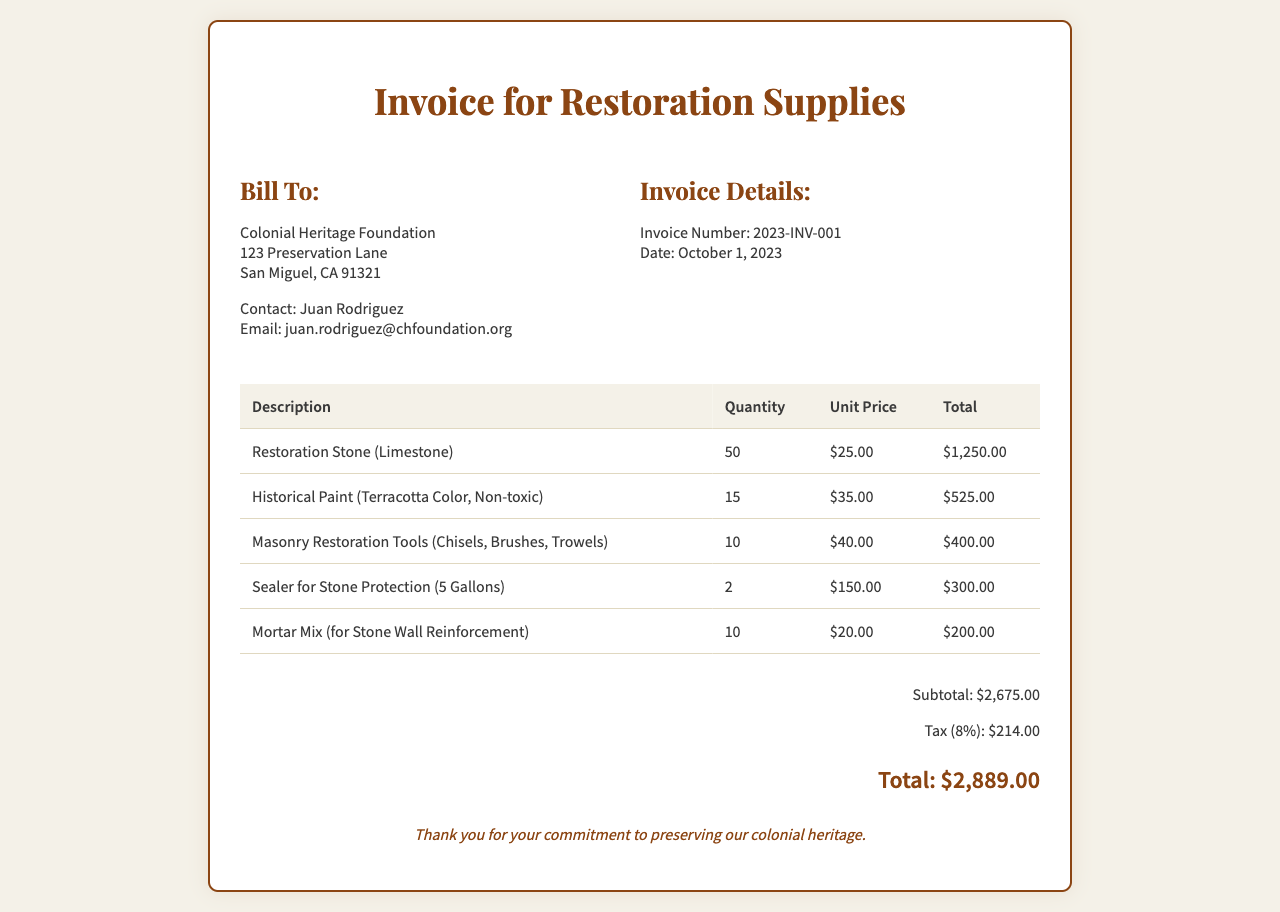What is the invoice number? The invoice number is provided in the invoice details section labeled as "Invoice Number."
Answer: 2023-INV-001 Who is the contact person for the Colonial Heritage Foundation? The contact person is listed under the "Bill To" section as "Contact."
Answer: Juan Rodriguez What is the total amount of the invoice? The total amount is noted at the bottom of the invoice in the total section.
Answer: $2,889.00 How many gallons of sealer for stone protection were purchased? The quantity of sealer is specified in the description under "Sealer for Stone Protection."
Answer: 2 What is the subtotal before tax? The subtotal can be found right before the tax calculation in the total section of the invoice.
Answer: $2,675.00 What is the tax rate applied to the subtotal? The tax information is included in the invoice details specifying the tax rate.
Answer: 8% What type of tools were included in the restoration supplies? The tools are listed in the description section and specify their type.
Answer: Masonry Restoration Tools When was the invoice issued? The date of the invoice is provided in the "Invoice Details" section labeled as "Date."
Answer: October 1, 2023 What color is the historical paint mentioned in the invoice? The color of the paint is mentioned in its description in the invoice.
Answer: Terracotta Color 